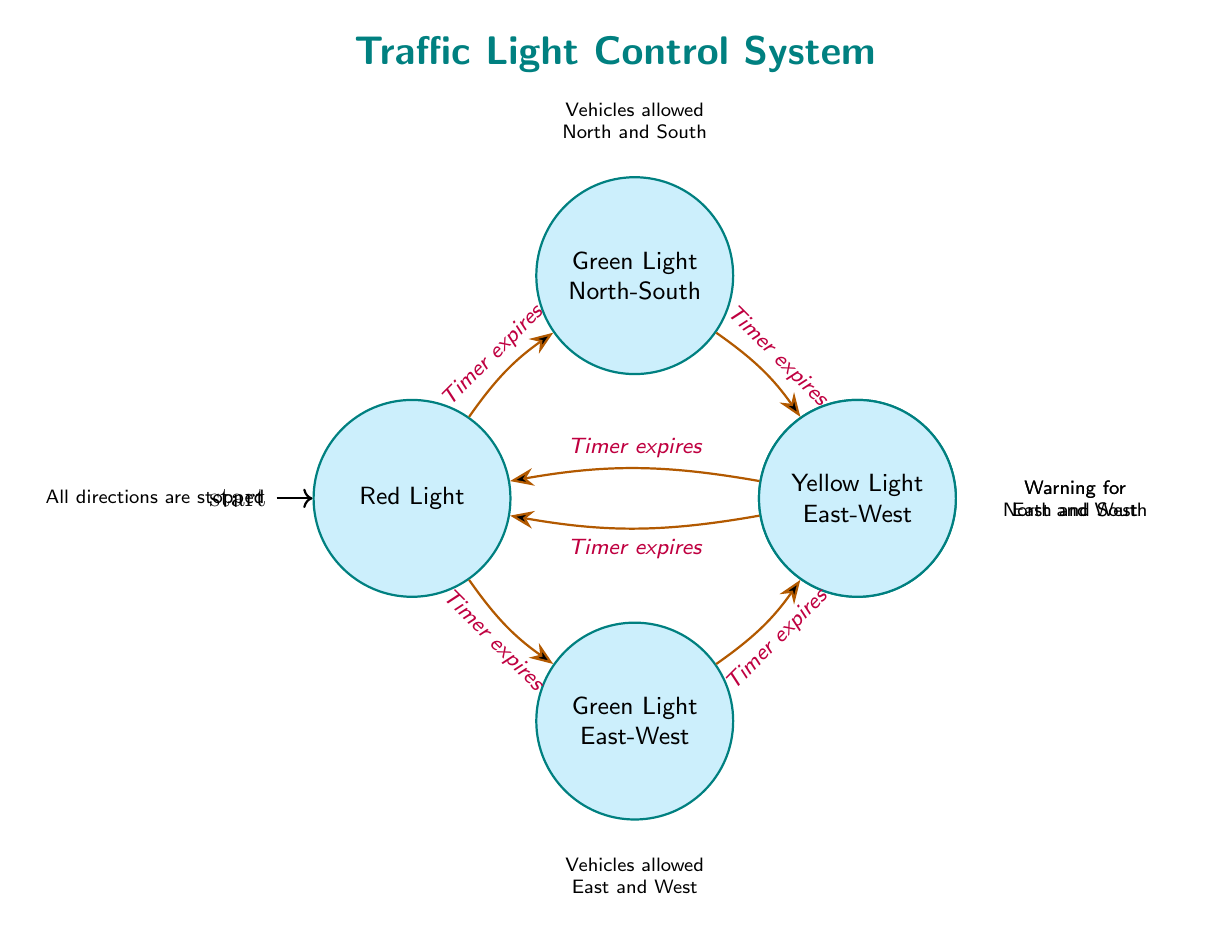What are the states represented in this diagram? The diagram lists five states: Red Light, Green Light - North-South, Yellow Light - North-South, Green Light - East-West, and Yellow Light - East-West.
Answer: Red Light, Green Light - North-South, Yellow Light - North-South, Green Light - East-West, Yellow Light - East-West How many transitions are there in total? By counting the transitions listed in the diagram, there are six transitions that describe the change from one state to another.
Answer: 6 What is the trigger for transitioning from Green Light - North-South to Yellow Light - North-South? The transition from Green Light - North-South to Yellow Light - North-South occurs when the timer expires, as per the labels on the transition in the diagram.
Answer: Timer expires In which state are all directions stopped? The state where all directions are stopped is identified in the diagram as Red Light, which is explicitly described in its description.
Answer: Red Light What state follows Yellow Light - East-West if the timer expires? According to the transitions, after Yellow Light - East-West, the next state is Red Light when the timer expires.
Answer: Red Light Which states allow vehicles to pass? The states Green Light - North-South and Green Light - East-West both allow vehicles to pass as described in their corresponding descriptions in the diagram.
Answer: Green Light - North-South, Green Light - East-West What state comes after Red Light if the timer expires? When the timer expires from the Red Light state, the next state is Green Light - North-South, indicating the transition of traffic flow for those directions.
Answer: Green Light - North-South What is the last state before returning to Red Light after Green Light - North-South? The state that occurs just before returning to Red Light from Green Light - North-South is Yellow Light - North-South, which serves as a warning phase.
Answer: Yellow Light - North-South What color light is shown for vehicles before transitioning to the Green Light - East-West? The color of the light before transitioning to the Green Light - East-West is Red Light, which indicates that all vehicles are stopped before the light changes.
Answer: Red Light 